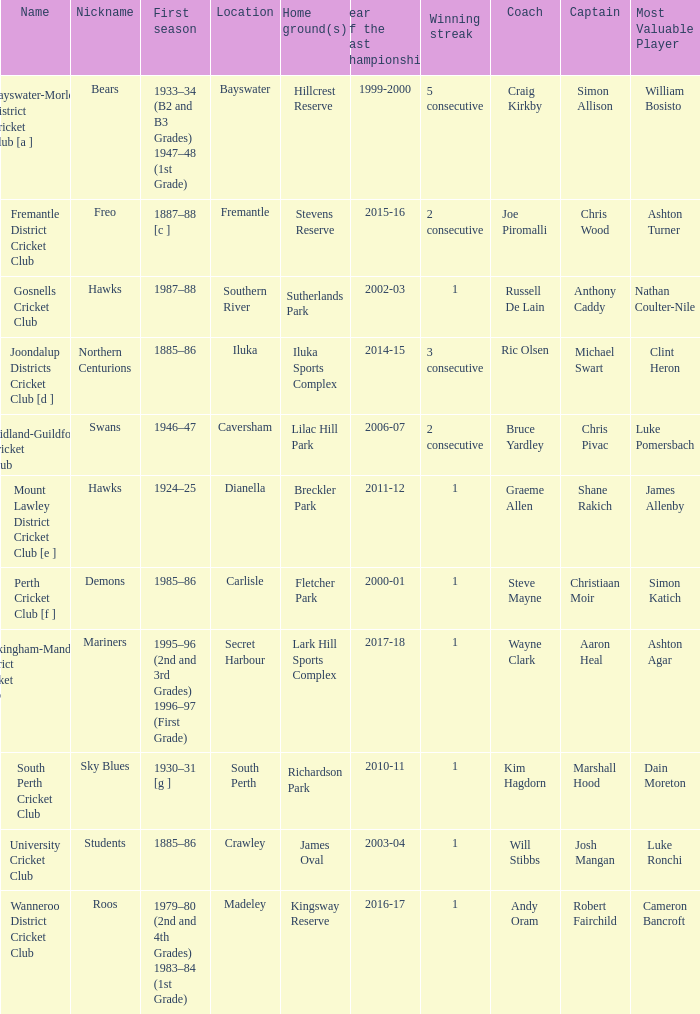Would you be able to parse every entry in this table? {'header': ['Name', 'Nickname', 'First season', 'Location', 'Home ground(s)', 'Year of the last championship', 'Winning streak', 'Coach', 'Captain', 'Most Valuable Player'], 'rows': [['Bayswater-Morley District Cricket Club [a ]', 'Bears', '1933–34 (B2 and B3 Grades) 1947–48 (1st Grade)', 'Bayswater', 'Hillcrest Reserve', '1999-2000', '5 consecutive', 'Craig Kirkby', 'Simon Allison', 'William Bosisto '], ['Fremantle District Cricket Club', 'Freo', '1887–88 [c ]', 'Fremantle', 'Stevens Reserve', '2015-16', '2 consecutive', 'Joe Piromalli', 'Chris Wood', 'Ashton Turner'], ['Gosnells Cricket Club', 'Hawks', '1987–88', 'Southern River', 'Sutherlands Park', '2002-03', '1', 'Russell De Lain', 'Anthony Caddy', 'Nathan Coulter-Nile'], ['Joondalup Districts Cricket Club [d ]', 'Northern Centurions', '1885–86', 'Iluka', 'Iluka Sports Complex', '2014-15', '3 consecutive', 'Ric Olsen', 'Michael Swart', 'Clint Heron'], ['Midland-Guildford Cricket Club', 'Swans', '1946–47', 'Caversham', 'Lilac Hill Park', '2006-07', '2 consecutive', 'Bruce Yardley', 'Chris Pivac', 'Luke Pomersbach'], ['Mount Lawley District Cricket Club [e ]', 'Hawks', '1924–25', 'Dianella', 'Breckler Park', '2011-12', '1', 'Graeme Allen', 'Shane Rakich', 'James Allenby'], ['Perth Cricket Club [f ]', 'Demons', '1985–86', 'Carlisle', 'Fletcher Park', '2000-01', '1', 'Steve Mayne', 'Christiaan Moir', 'Simon Katich'], ['Rockingham-Mandurah District Cricket Club', 'Mariners', '1995–96 (2nd and 3rd Grades) 1996–97 (First Grade)', 'Secret Harbour', 'Lark Hill Sports Complex', '2017-18', '1', 'Wayne Clark', 'Aaron Heal', 'Ashton Agar'], ['South Perth Cricket Club', 'Sky Blues', '1930–31 [g ]', 'South Perth', 'Richardson Park', '2010-11', '1', 'Kim Hagdorn', 'Marshall Hood', 'Dain Moreton'], ['University Cricket Club', 'Students', '1885–86', 'Crawley', 'James Oval', '2003-04', '1', 'Will Stibbs', 'Josh Mangan', 'Luke Ronchi'], ['Wanneroo District Cricket Club', 'Roos', '1979–80 (2nd and 4th Grades) 1983–84 (1st Grade)', 'Madeley', 'Kingsway Reserve', '2016-17', '1', 'Andy Oram', 'Robert Fairchild', 'Cameron Bancroft']]} What is the location for the club with the nickname the bears? Bayswater. 